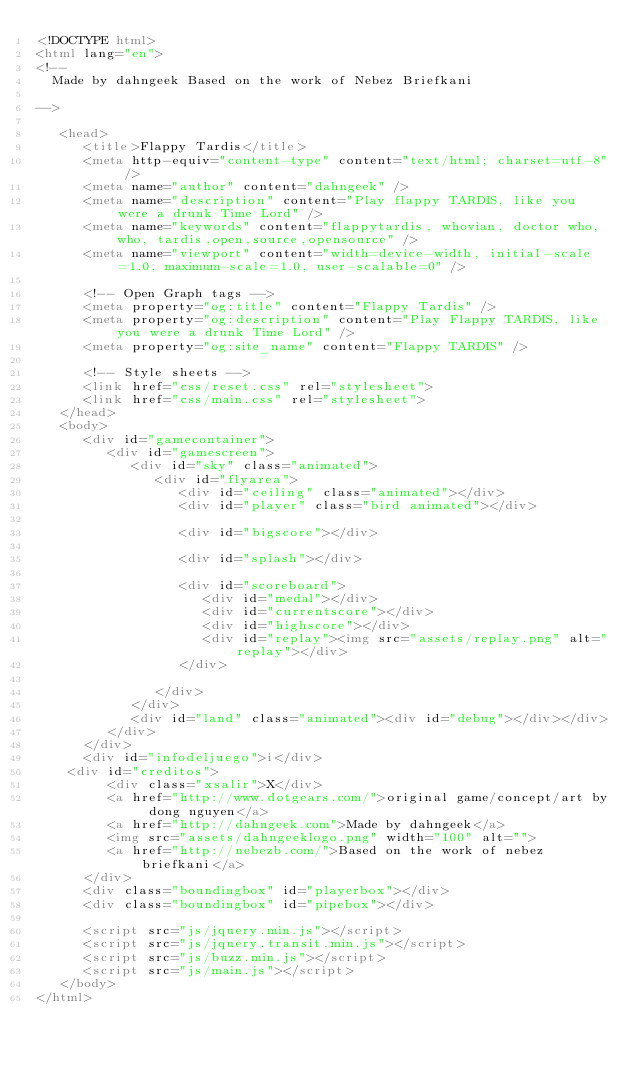Convert code to text. <code><loc_0><loc_0><loc_500><loc_500><_HTML_><!DOCTYPE html>
<html lang="en">
<!--
  Made by dahngeek Based on the work of Nebez Briefkani

-->

   <head>
      <title>Flappy Tardis</title>
      <meta http-equiv="content-type" content="text/html; charset=utf-8" />
      <meta name="author" content="dahngeek" />
      <meta name="description" content="Play flappy TARDIS, like you were a drunk Time Lord" />
      <meta name="keywords" content="flappytardis, whovian, doctor who, who, tardis,open,source,opensource" />
      <meta name="viewport" content="width=device-width, initial-scale=1.0, maximum-scale=1.0, user-scalable=0" />

      <!-- Open Graph tags -->
      <meta property="og:title" content="Flappy Tardis" />
      <meta property="og:description" content="Play Flappy TARDIS, like you were a drunk Time Lord" />
      <meta property="og:site_name" content="Flappy TARDIS" />
      
      <!-- Style sheets -->
      <link href="css/reset.css" rel="stylesheet">
      <link href="css/main.css" rel="stylesheet">
   </head>
   <body>
      <div id="gamecontainer">
         <div id="gamescreen">
            <div id="sky" class="animated">
               <div id="flyarea">
                  <div id="ceiling" class="animated"></div>
                  <div id="player" class="bird animated"></div>
                  
                  <div id="bigscore"></div>
                  
                  <div id="splash"></div>
                  
                  <div id="scoreboard">
                     <div id="medal"></div>
                     <div id="currentscore"></div>
                     <div id="highscore"></div>
                     <div id="replay"><img src="assets/replay.png" alt="replay"></div>
                  </div>
                  
               </div>
            </div>
            <div id="land" class="animated"><div id="debug"></div></div>
         </div>
      </div>
      <div id="infodeljuego">i</div>
    <div id="creditos">
         <div class="xsalir">X</div>
         <a href="http://www.dotgears.com/">original game/concept/art by dong nguyen</a>
         <a href="http://dahngeek.com">Made by dahngeek</a>
         <img src="assets/dahngeeklogo.png" width="100" alt="">
         <a href="http://nebezb.com/">Based on the work of nebez briefkani</a>
      </div>   
      <div class="boundingbox" id="playerbox"></div>
      <div class="boundingbox" id="pipebox"></div>
      
      <script src="js/jquery.min.js"></script>
      <script src="js/jquery.transit.min.js"></script>
      <script src="js/buzz.min.js"></script>
      <script src="js/main.js"></script>
   </body>
</html></code> 